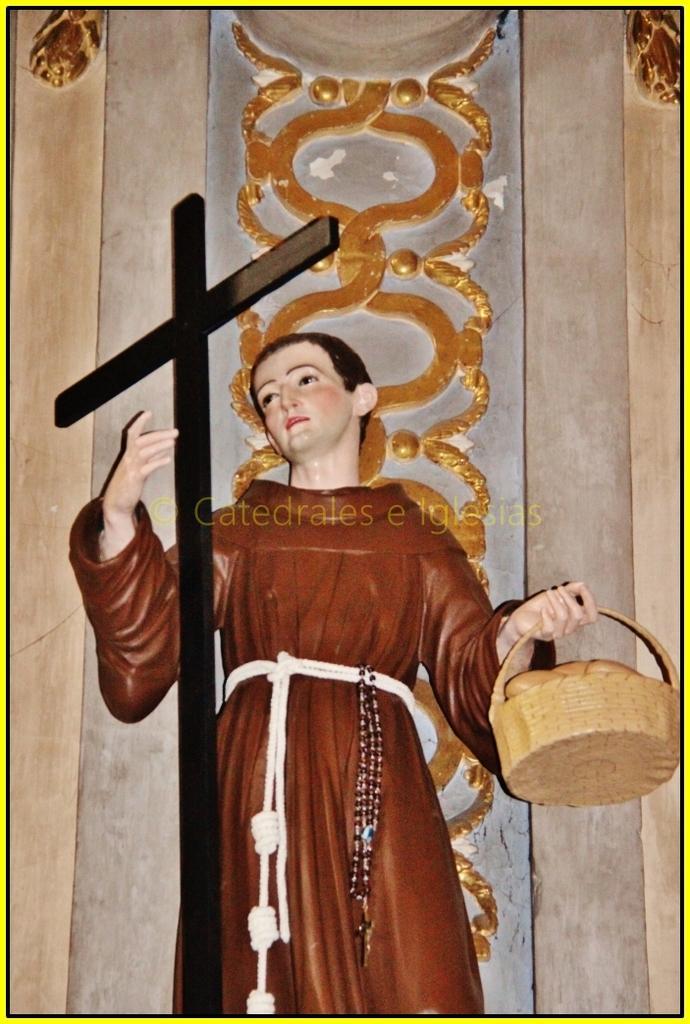Describe this image in one or two sentences. In this image we can see a statue of a person holding a basket. Near to him there is a cross. In the back there is a wall. Around the waist of the person there are ropes. Also there is a rosary. 